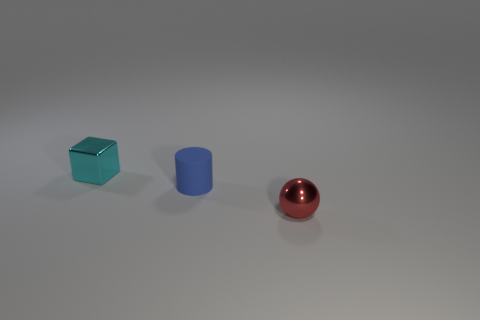Add 1 cyan rubber blocks. How many objects exist? 4 Subtract all cylinders. How many objects are left? 2 Subtract all big matte things. Subtract all small spheres. How many objects are left? 2 Add 1 cylinders. How many cylinders are left? 2 Add 2 tiny brown matte cylinders. How many tiny brown matte cylinders exist? 2 Subtract 1 cyan cubes. How many objects are left? 2 